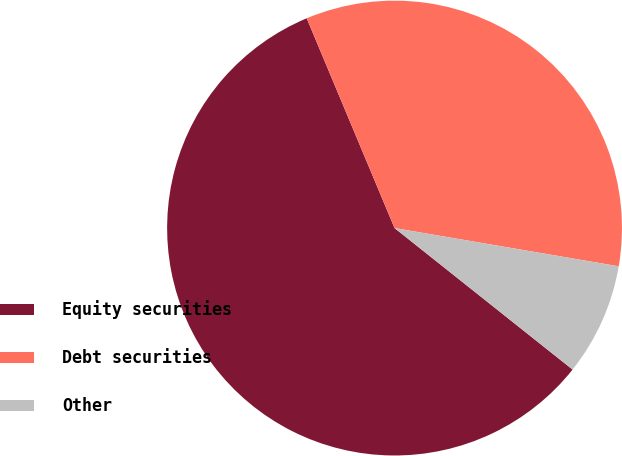Convert chart to OTSL. <chart><loc_0><loc_0><loc_500><loc_500><pie_chart><fcel>Equity securities<fcel>Debt securities<fcel>Other<nl><fcel>58.0%<fcel>34.0%<fcel>8.0%<nl></chart> 